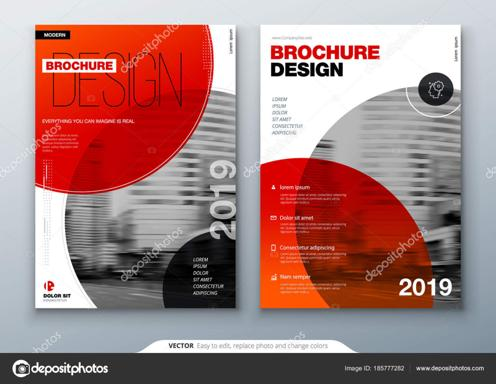How environmentally friendly is this brochure? While I cannot discern the specific materials used directly from the image, presenting a brochure using recycled paper or sustainable inks could enhance an organization's commitment to environmental responsibility. It’s advisable for companies to consider eco-friendly options to appeal to environmentally conscious consumers. 